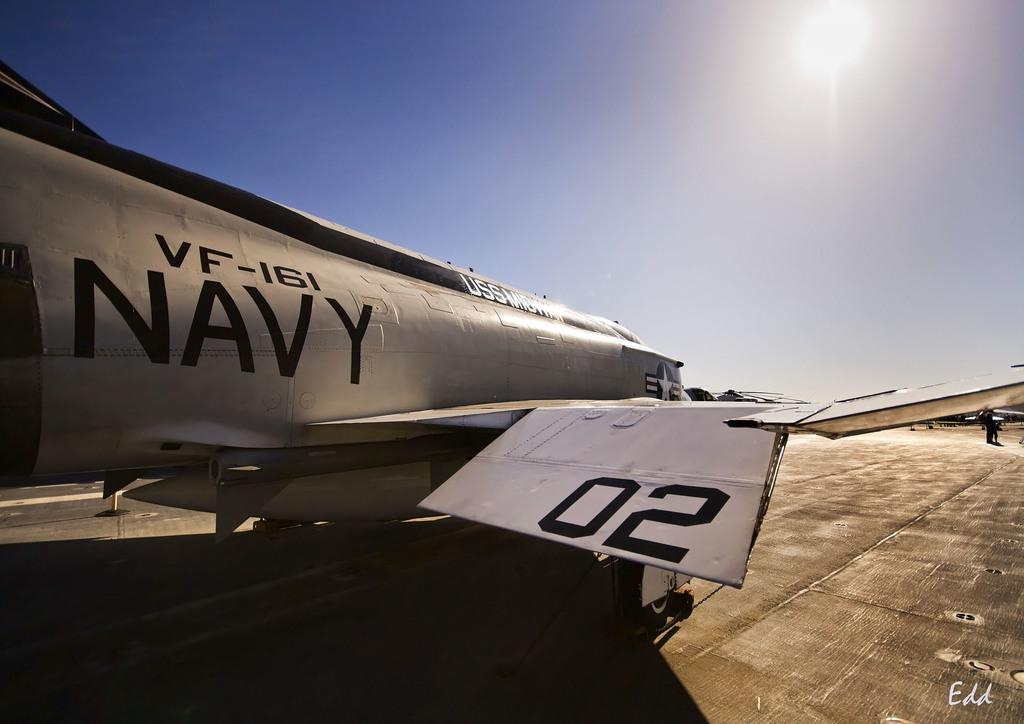<image>
Relay a brief, clear account of the picture shown. A grey navy fighter plane is from VF-161. 